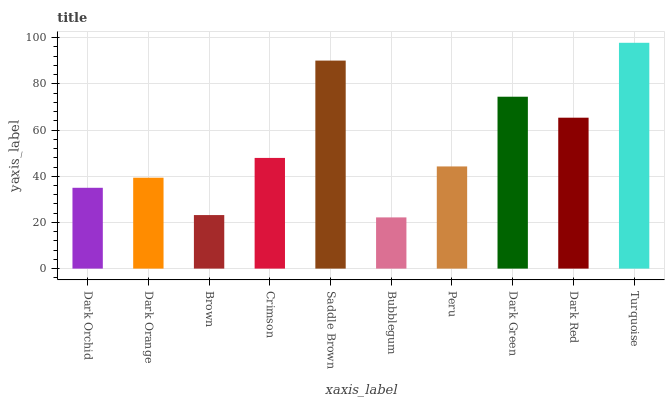Is Bubblegum the minimum?
Answer yes or no. Yes. Is Turquoise the maximum?
Answer yes or no. Yes. Is Dark Orange the minimum?
Answer yes or no. No. Is Dark Orange the maximum?
Answer yes or no. No. Is Dark Orange greater than Dark Orchid?
Answer yes or no. Yes. Is Dark Orchid less than Dark Orange?
Answer yes or no. Yes. Is Dark Orchid greater than Dark Orange?
Answer yes or no. No. Is Dark Orange less than Dark Orchid?
Answer yes or no. No. Is Crimson the high median?
Answer yes or no. Yes. Is Peru the low median?
Answer yes or no. Yes. Is Dark Red the high median?
Answer yes or no. No. Is Turquoise the low median?
Answer yes or no. No. 